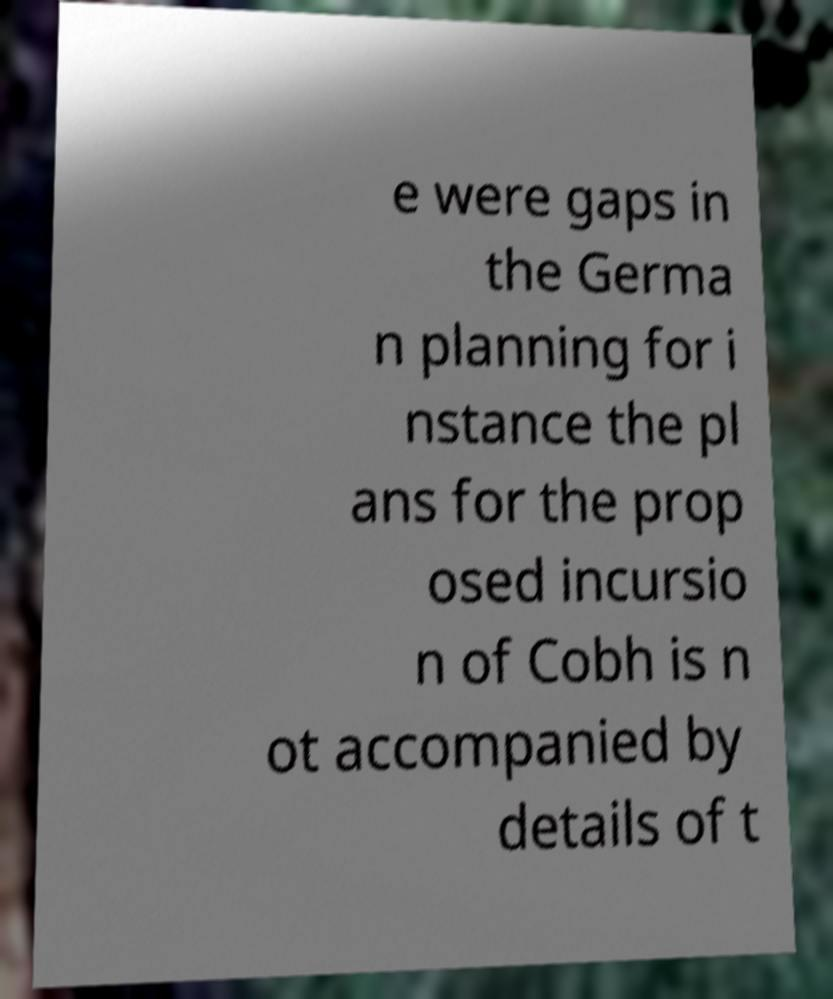Can you read and provide the text displayed in the image?This photo seems to have some interesting text. Can you extract and type it out for me? e were gaps in the Germa n planning for i nstance the pl ans for the prop osed incursio n of Cobh is n ot accompanied by details of t 